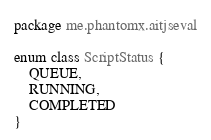<code> <loc_0><loc_0><loc_500><loc_500><_Kotlin_>package me.phantomx.aitjseval

enum class ScriptStatus {
    QUEUE,
    RUNNING,
    COMPLETED
}</code> 